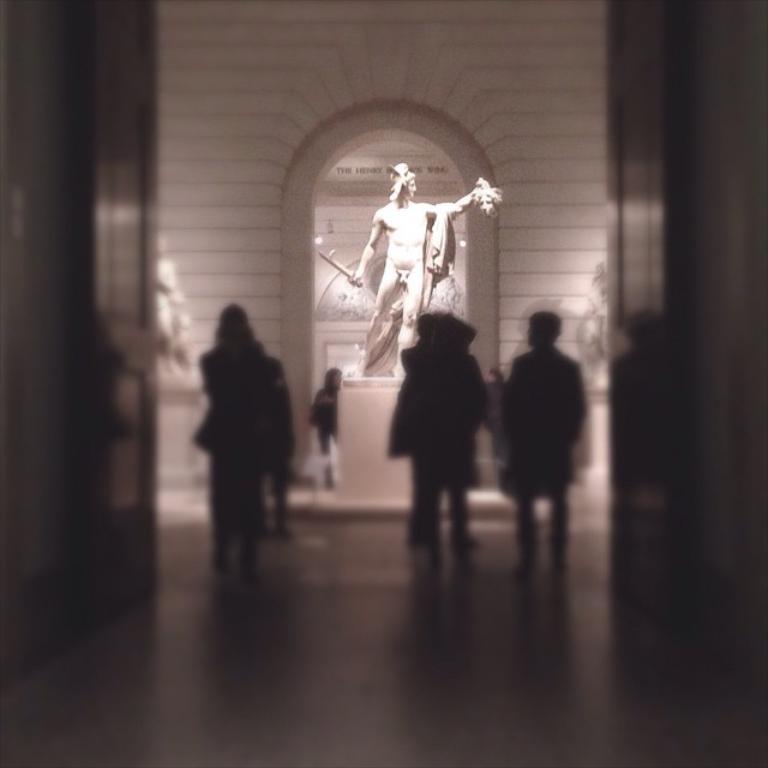Can you describe this image briefly? In this image there are people standing on a floor and it is blurred, in the background there is a statute, behind the statute there is a wall. 